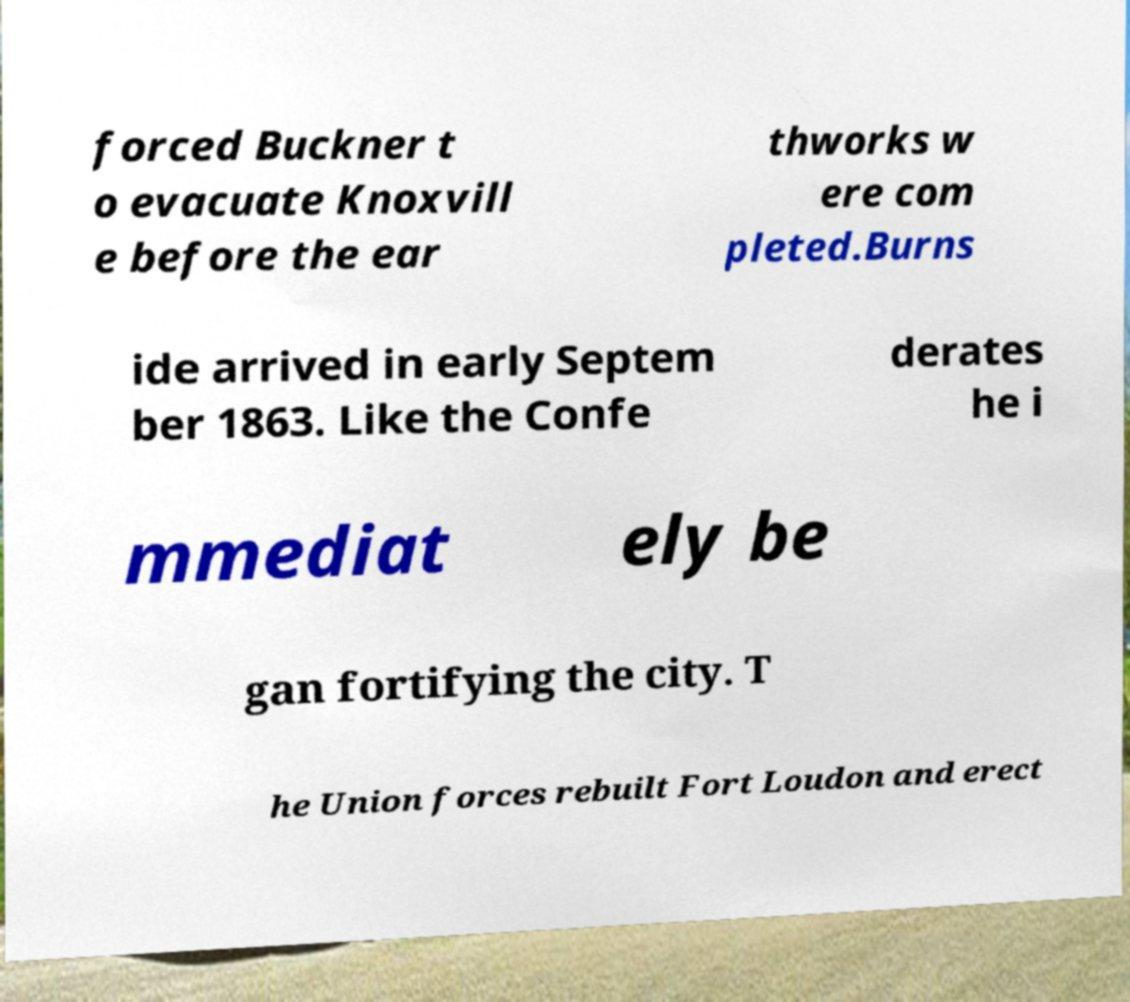Can you accurately transcribe the text from the provided image for me? forced Buckner t o evacuate Knoxvill e before the ear thworks w ere com pleted.Burns ide arrived in early Septem ber 1863. Like the Confe derates he i mmediat ely be gan fortifying the city. T he Union forces rebuilt Fort Loudon and erect 